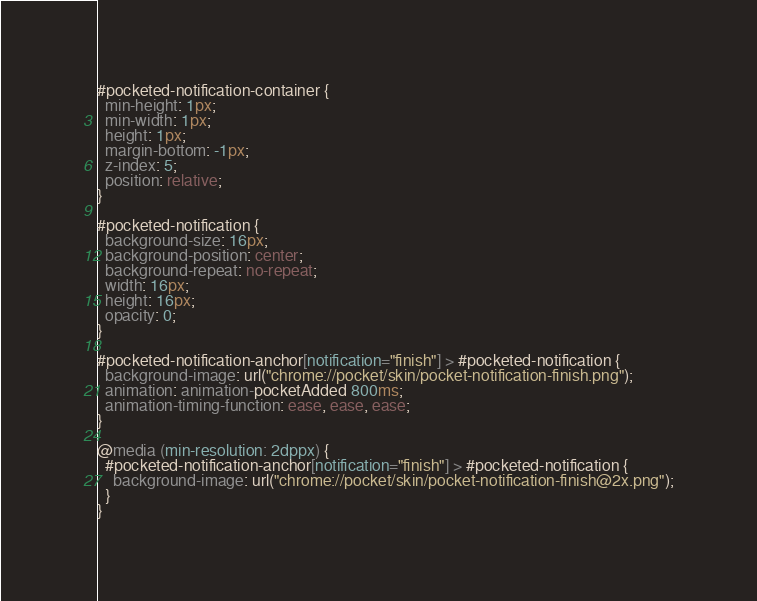<code> <loc_0><loc_0><loc_500><loc_500><_CSS_>
#pocketed-notification-container {
  min-height: 1px;
  min-width: 1px;
  height: 1px;
  margin-bottom: -1px;
  z-index: 5;
  position: relative;
}

#pocketed-notification {
  background-size: 16px;
  background-position: center;
  background-repeat: no-repeat;
  width: 16px;
  height: 16px;
  opacity: 0;
}

#pocketed-notification-anchor[notification="finish"] > #pocketed-notification {
  background-image: url("chrome://pocket/skin/pocket-notification-finish.png");
  animation: animation-pocketAdded 800ms;
  animation-timing-function: ease, ease, ease;
}

@media (min-resolution: 2dppx) {
  #pocketed-notification-anchor[notification="finish"] > #pocketed-notification {
    background-image: url("chrome://pocket/skin/pocket-notification-finish@2x.png");
  }
}</code> 